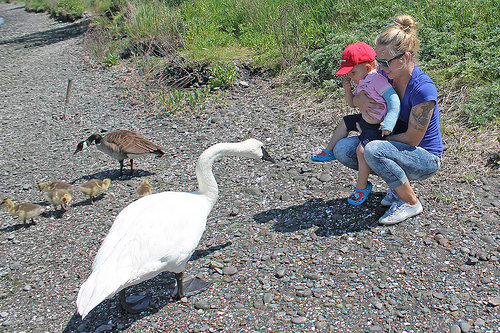<image>
Is the baby in front of the goose? No. The baby is not in front of the goose. The spatial positioning shows a different relationship between these objects. 